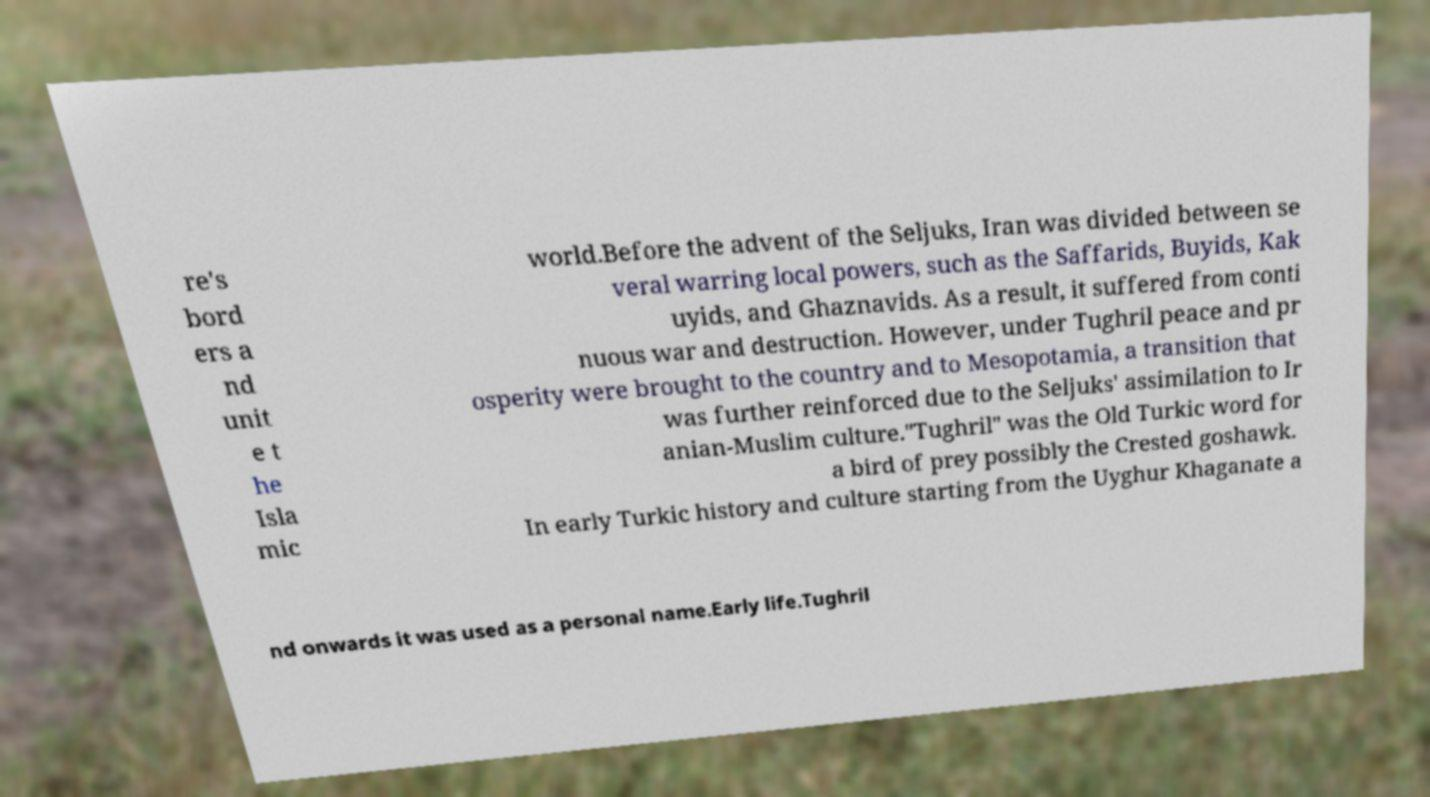Could you extract and type out the text from this image? re's bord ers a nd unit e t he Isla mic world.Before the advent of the Seljuks, Iran was divided between se veral warring local powers, such as the Saffarids, Buyids, Kak uyids, and Ghaznavids. As a result, it suffered from conti nuous war and destruction. However, under Tughril peace and pr osperity were brought to the country and to Mesopotamia, a transition that was further reinforced due to the Seljuks' assimilation to Ir anian-Muslim culture."Tughril" was the Old Turkic word for a bird of prey possibly the Crested goshawk. In early Turkic history and culture starting from the Uyghur Khaganate a nd onwards it was used as a personal name.Early life.Tughril 